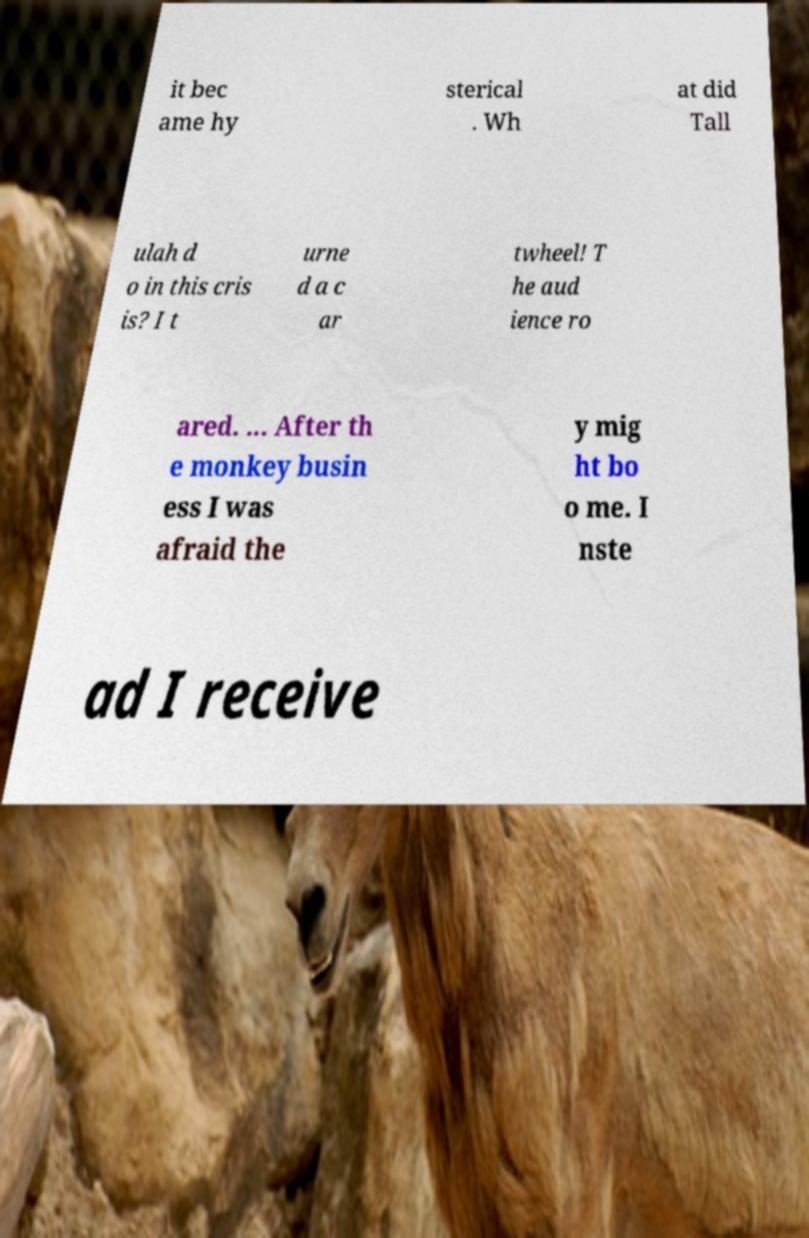What messages or text are displayed in this image? I need them in a readable, typed format. it bec ame hy sterical . Wh at did Tall ulah d o in this cris is? I t urne d a c ar twheel! T he aud ience ro ared. ... After th e monkey busin ess I was afraid the y mig ht bo o me. I nste ad I receive 